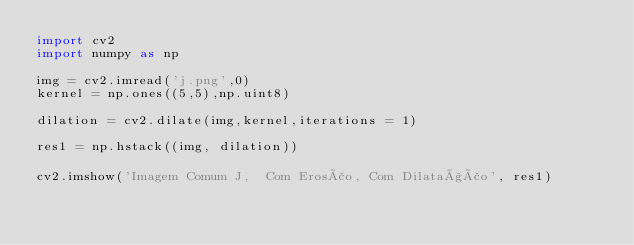<code> <loc_0><loc_0><loc_500><loc_500><_Python_>import cv2
import numpy as np

img = cv2.imread('j.png',0)
kernel = np.ones((5,5),np.uint8)

dilation = cv2.dilate(img,kernel,iterations = 1)

res1 = np.hstack((img, dilation))

cv2.imshow('Imagem Comum J,  Com Erosão, Com Dilatação', res1)</code> 